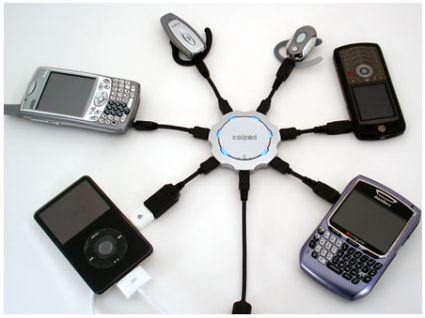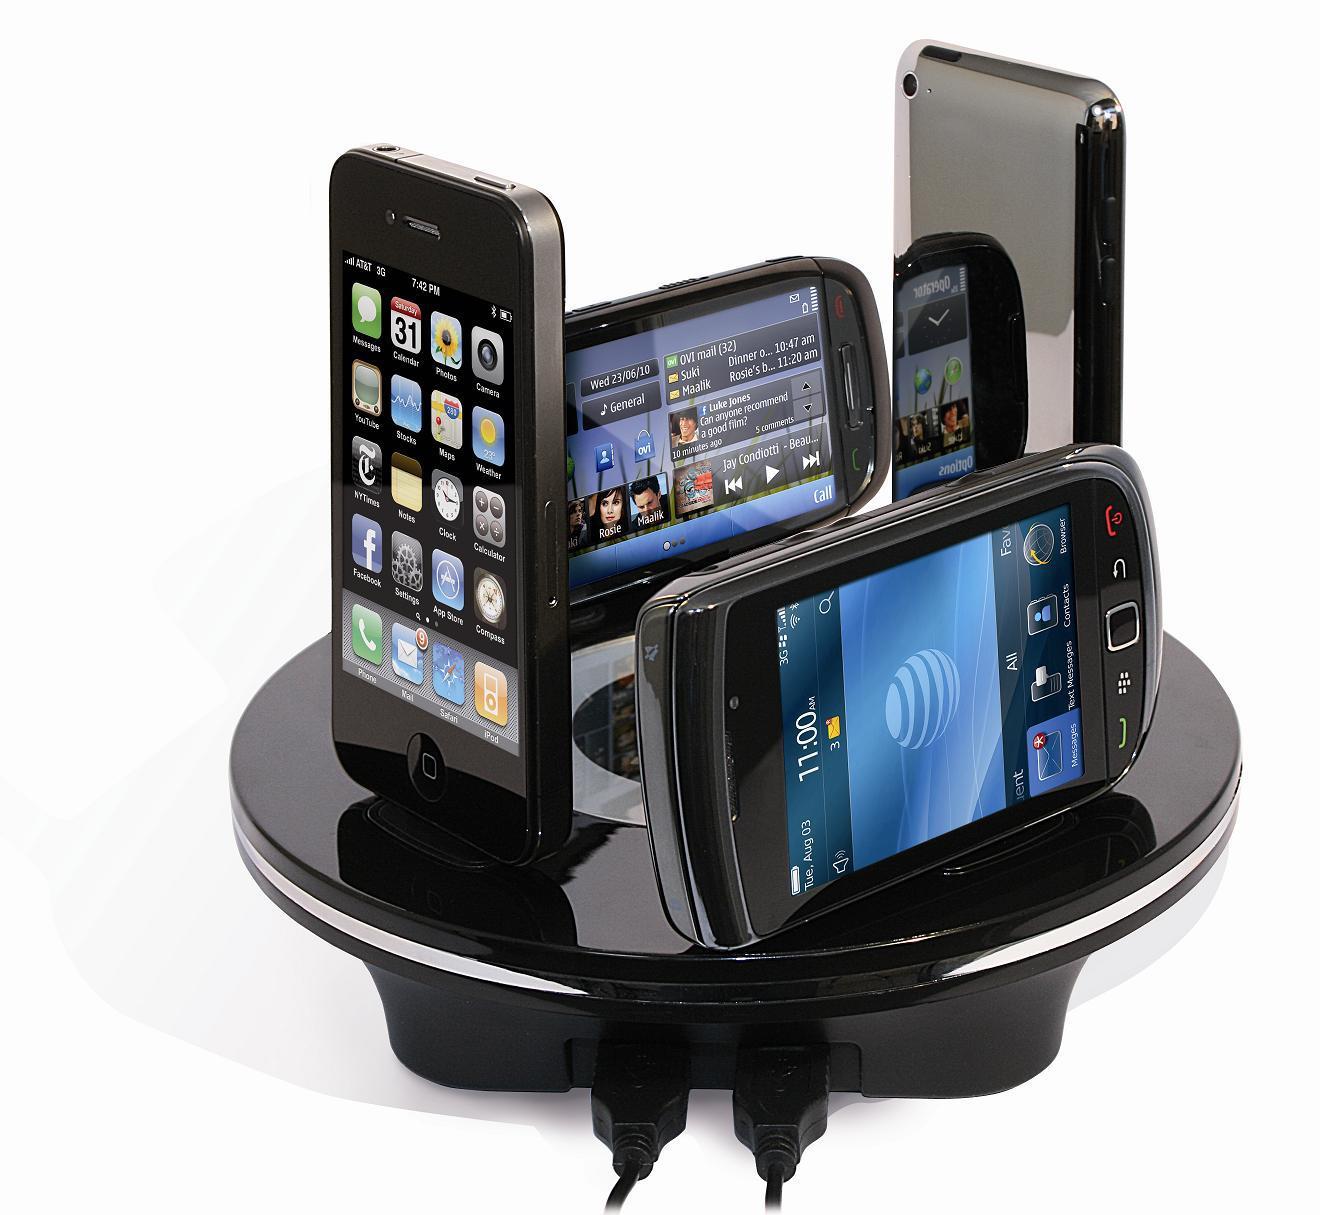The first image is the image on the left, the second image is the image on the right. Analyze the images presented: Is the assertion "There is a single cell phone in the image on the left and at least twice as many on the right." valid? Answer yes or no. No. The first image is the image on the left, the second image is the image on the right. Examine the images to the left and right. Is the description "There is a single phone in the left image." accurate? Answer yes or no. No. 